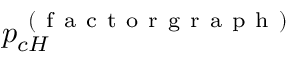<formula> <loc_0><loc_0><loc_500><loc_500>p _ { c H } ^ { ( f a c t o r g r a p h ) }</formula> 